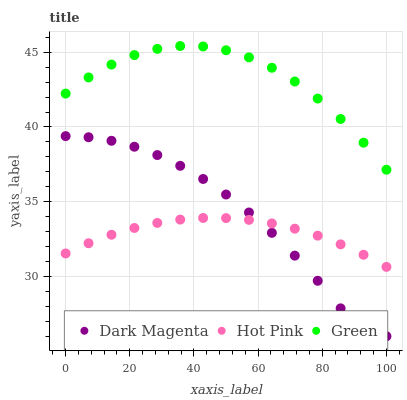Does Hot Pink have the minimum area under the curve?
Answer yes or no. Yes. Does Green have the maximum area under the curve?
Answer yes or no. Yes. Does Dark Magenta have the minimum area under the curve?
Answer yes or no. No. Does Dark Magenta have the maximum area under the curve?
Answer yes or no. No. Is Hot Pink the smoothest?
Answer yes or no. Yes. Is Dark Magenta the roughest?
Answer yes or no. Yes. Is Green the smoothest?
Answer yes or no. No. Is Green the roughest?
Answer yes or no. No. Does Dark Magenta have the lowest value?
Answer yes or no. Yes. Does Green have the lowest value?
Answer yes or no. No. Does Green have the highest value?
Answer yes or no. Yes. Does Dark Magenta have the highest value?
Answer yes or no. No. Is Hot Pink less than Green?
Answer yes or no. Yes. Is Green greater than Dark Magenta?
Answer yes or no. Yes. Does Dark Magenta intersect Hot Pink?
Answer yes or no. Yes. Is Dark Magenta less than Hot Pink?
Answer yes or no. No. Is Dark Magenta greater than Hot Pink?
Answer yes or no. No. Does Hot Pink intersect Green?
Answer yes or no. No. 